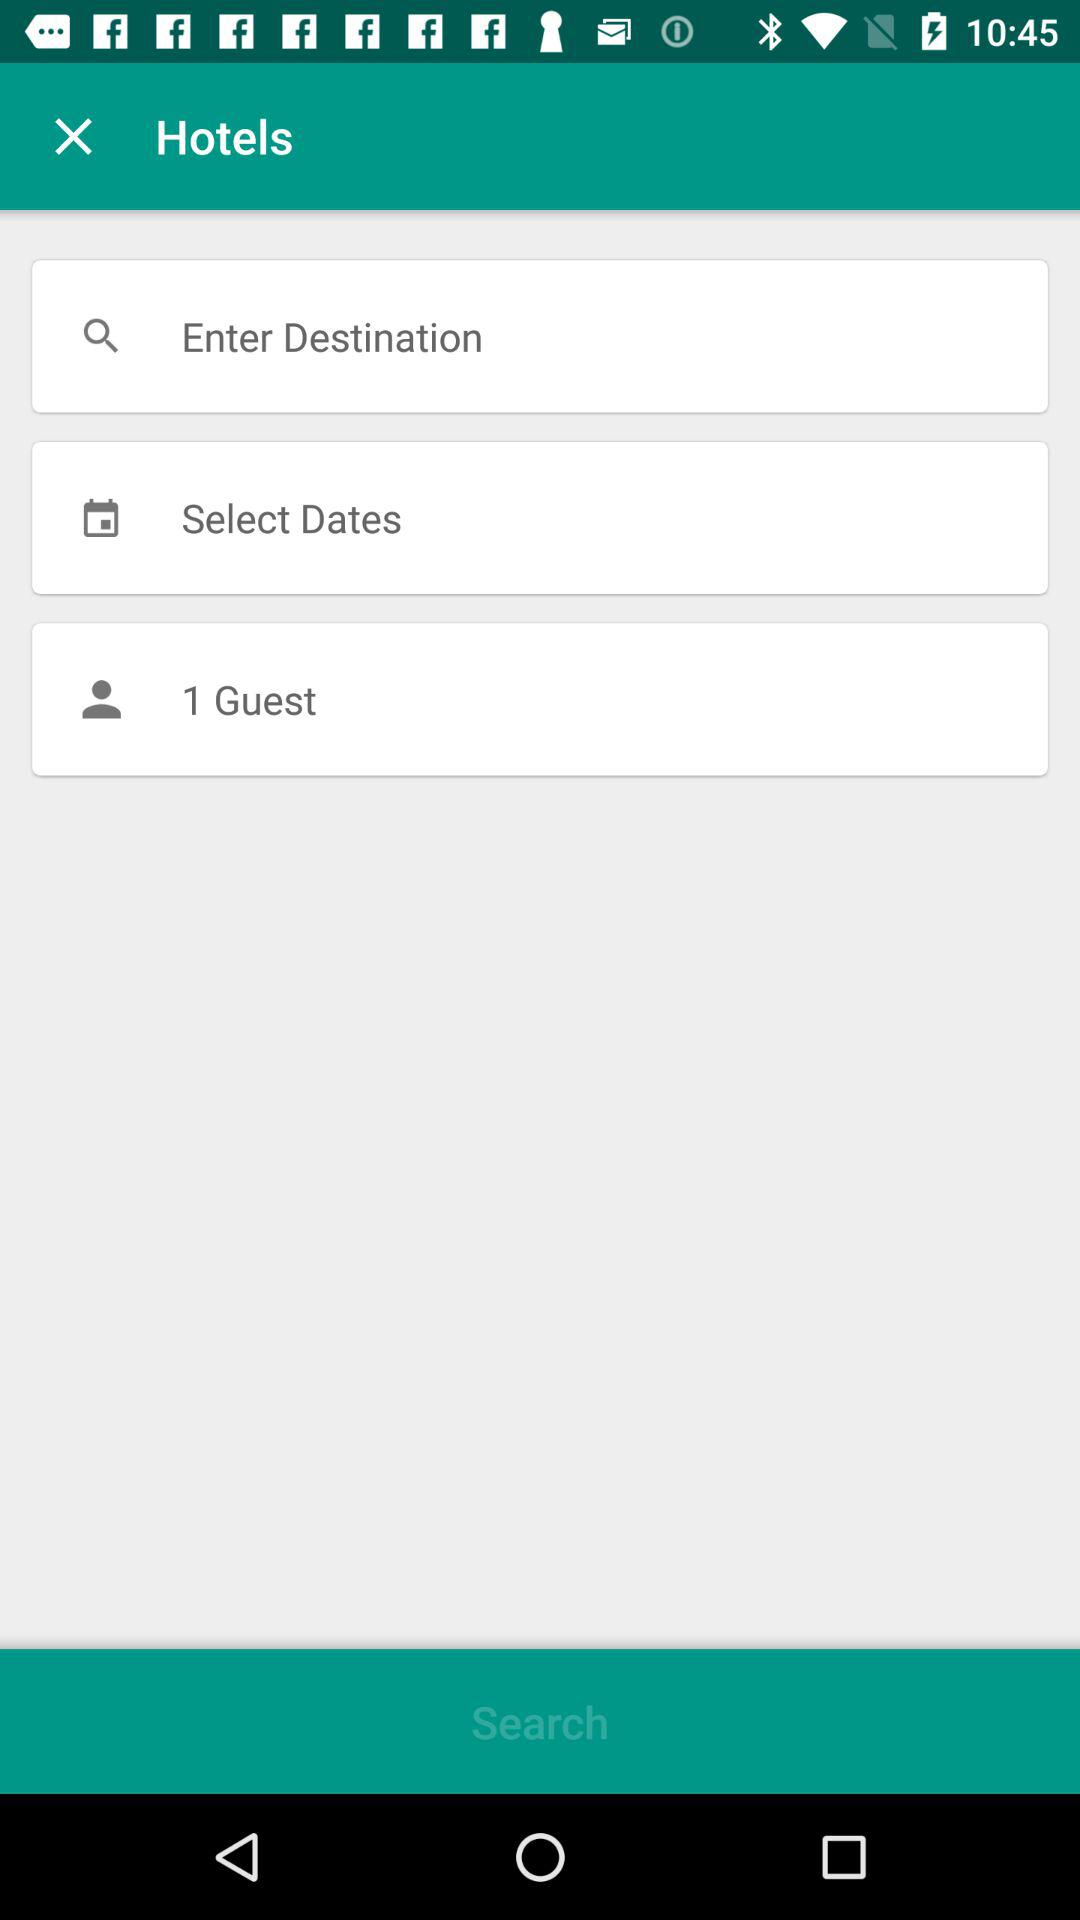How many guests are shown on the screen? There is 1 guest shown on the screen. 